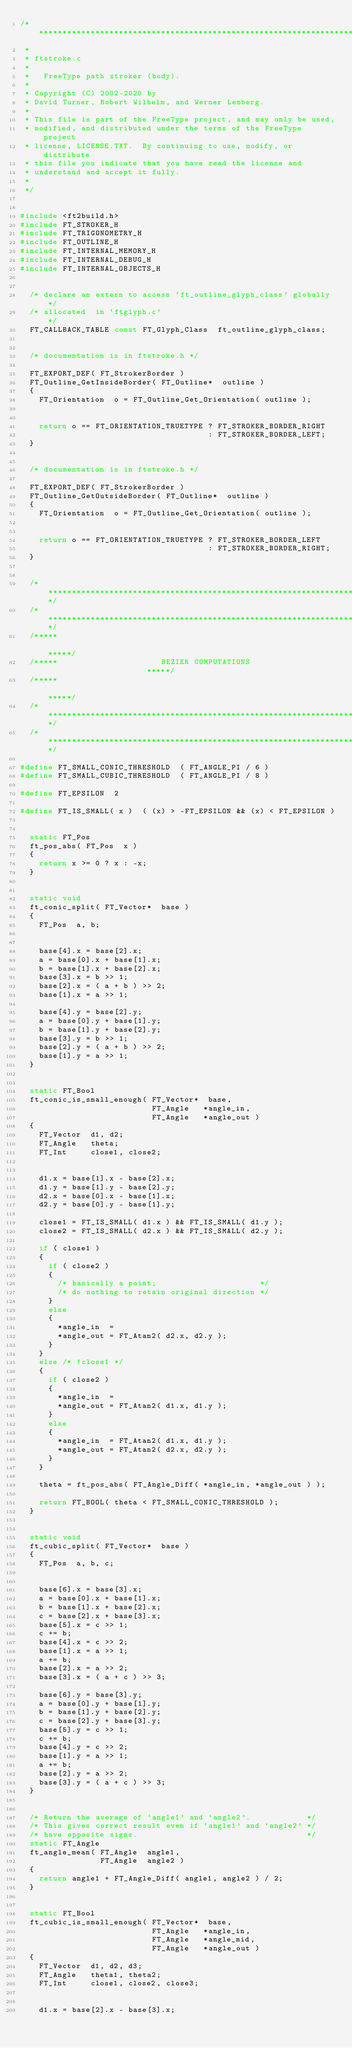Convert code to text. <code><loc_0><loc_0><loc_500><loc_500><_C_>/****************************************************************************
 *
 * ftstroke.c
 *
 *   FreeType path stroker (body).
 *
 * Copyright (C) 2002-2020 by
 * David Turner, Robert Wilhelm, and Werner Lemberg.
 *
 * This file is part of the FreeType project, and may only be used,
 * modified, and distributed under the terms of the FreeType project
 * license, LICENSE.TXT.  By continuing to use, modify, or distribute
 * this file you indicate that you have read the license and
 * understand and accept it fully.
 *
 */


#include <ft2build.h>
#include FT_STROKER_H
#include FT_TRIGONOMETRY_H
#include FT_OUTLINE_H
#include FT_INTERNAL_MEMORY_H
#include FT_INTERNAL_DEBUG_H
#include FT_INTERNAL_OBJECTS_H


  /* declare an extern to access `ft_outline_glyph_class' globally */
  /* allocated  in `ftglyph.c'                                     */
  FT_CALLBACK_TABLE const FT_Glyph_Class  ft_outline_glyph_class;


  /* documentation is in ftstroke.h */

  FT_EXPORT_DEF( FT_StrokerBorder )
  FT_Outline_GetInsideBorder( FT_Outline*  outline )
  {
    FT_Orientation  o = FT_Outline_Get_Orientation( outline );


    return o == FT_ORIENTATION_TRUETYPE ? FT_STROKER_BORDER_RIGHT
                                        : FT_STROKER_BORDER_LEFT;
  }


  /* documentation is in ftstroke.h */

  FT_EXPORT_DEF( FT_StrokerBorder )
  FT_Outline_GetOutsideBorder( FT_Outline*  outline )
  {
    FT_Orientation  o = FT_Outline_Get_Orientation( outline );


    return o == FT_ORIENTATION_TRUETYPE ? FT_STROKER_BORDER_LEFT
                                        : FT_STROKER_BORDER_RIGHT;
  }


  /*************************************************************************/
  /*************************************************************************/
  /*****                                                               *****/
  /*****                      BEZIER COMPUTATIONS                      *****/
  /*****                                                               *****/
  /*************************************************************************/
  /*************************************************************************/

#define FT_SMALL_CONIC_THRESHOLD  ( FT_ANGLE_PI / 6 )
#define FT_SMALL_CUBIC_THRESHOLD  ( FT_ANGLE_PI / 8 )

#define FT_EPSILON  2

#define FT_IS_SMALL( x )  ( (x) > -FT_EPSILON && (x) < FT_EPSILON )


  static FT_Pos
  ft_pos_abs( FT_Pos  x )
  {
    return x >= 0 ? x : -x;
  }


  static void
  ft_conic_split( FT_Vector*  base )
  {
    FT_Pos  a, b;


    base[4].x = base[2].x;
    a = base[0].x + base[1].x;
    b = base[1].x + base[2].x;
    base[3].x = b >> 1;
    base[2].x = ( a + b ) >> 2;
    base[1].x = a >> 1;

    base[4].y = base[2].y;
    a = base[0].y + base[1].y;
    b = base[1].y + base[2].y;
    base[3].y = b >> 1;
    base[2].y = ( a + b ) >> 2;
    base[1].y = a >> 1;
  }


  static FT_Bool
  ft_conic_is_small_enough( FT_Vector*  base,
                            FT_Angle   *angle_in,
                            FT_Angle   *angle_out )
  {
    FT_Vector  d1, d2;
    FT_Angle   theta;
    FT_Int     close1, close2;


    d1.x = base[1].x - base[2].x;
    d1.y = base[1].y - base[2].y;
    d2.x = base[0].x - base[1].x;
    d2.y = base[0].y - base[1].y;

    close1 = FT_IS_SMALL( d1.x ) && FT_IS_SMALL( d1.y );
    close2 = FT_IS_SMALL( d2.x ) && FT_IS_SMALL( d2.y );

    if ( close1 )
    {
      if ( close2 )
      {
        /* basically a point;                      */
        /* do nothing to retain original direction */
      }
      else
      {
        *angle_in  =
        *angle_out = FT_Atan2( d2.x, d2.y );
      }
    }
    else /* !close1 */
    {
      if ( close2 )
      {
        *angle_in  =
        *angle_out = FT_Atan2( d1.x, d1.y );
      }
      else
      {
        *angle_in  = FT_Atan2( d1.x, d1.y );
        *angle_out = FT_Atan2( d2.x, d2.y );
      }
    }

    theta = ft_pos_abs( FT_Angle_Diff( *angle_in, *angle_out ) );

    return FT_BOOL( theta < FT_SMALL_CONIC_THRESHOLD );
  }


  static void
  ft_cubic_split( FT_Vector*  base )
  {
    FT_Pos  a, b, c;


    base[6].x = base[3].x;
    a = base[0].x + base[1].x;
    b = base[1].x + base[2].x;
    c = base[2].x + base[3].x;
    base[5].x = c >> 1;
    c += b;
    base[4].x = c >> 2;
    base[1].x = a >> 1;
    a += b;
    base[2].x = a >> 2;
    base[3].x = ( a + c ) >> 3;

    base[6].y = base[3].y;
    a = base[0].y + base[1].y;
    b = base[1].y + base[2].y;
    c = base[2].y + base[3].y;
    base[5].y = c >> 1;
    c += b;
    base[4].y = c >> 2;
    base[1].y = a >> 1;
    a += b;
    base[2].y = a >> 2;
    base[3].y = ( a + c ) >> 3;
  }


  /* Return the average of `angle1' and `angle2'.            */
  /* This gives correct result even if `angle1' and `angle2' */
  /* have opposite signs.                                    */
  static FT_Angle
  ft_angle_mean( FT_Angle  angle1,
                 FT_Angle  angle2 )
  {
    return angle1 + FT_Angle_Diff( angle1, angle2 ) / 2;
  }


  static FT_Bool
  ft_cubic_is_small_enough( FT_Vector*  base,
                            FT_Angle   *angle_in,
                            FT_Angle   *angle_mid,
                            FT_Angle   *angle_out )
  {
    FT_Vector  d1, d2, d3;
    FT_Angle   theta1, theta2;
    FT_Int     close1, close2, close3;


    d1.x = base[2].x - base[3].x;</code> 